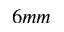<formula> <loc_0><loc_0><loc_500><loc_500>6 m m</formula> 